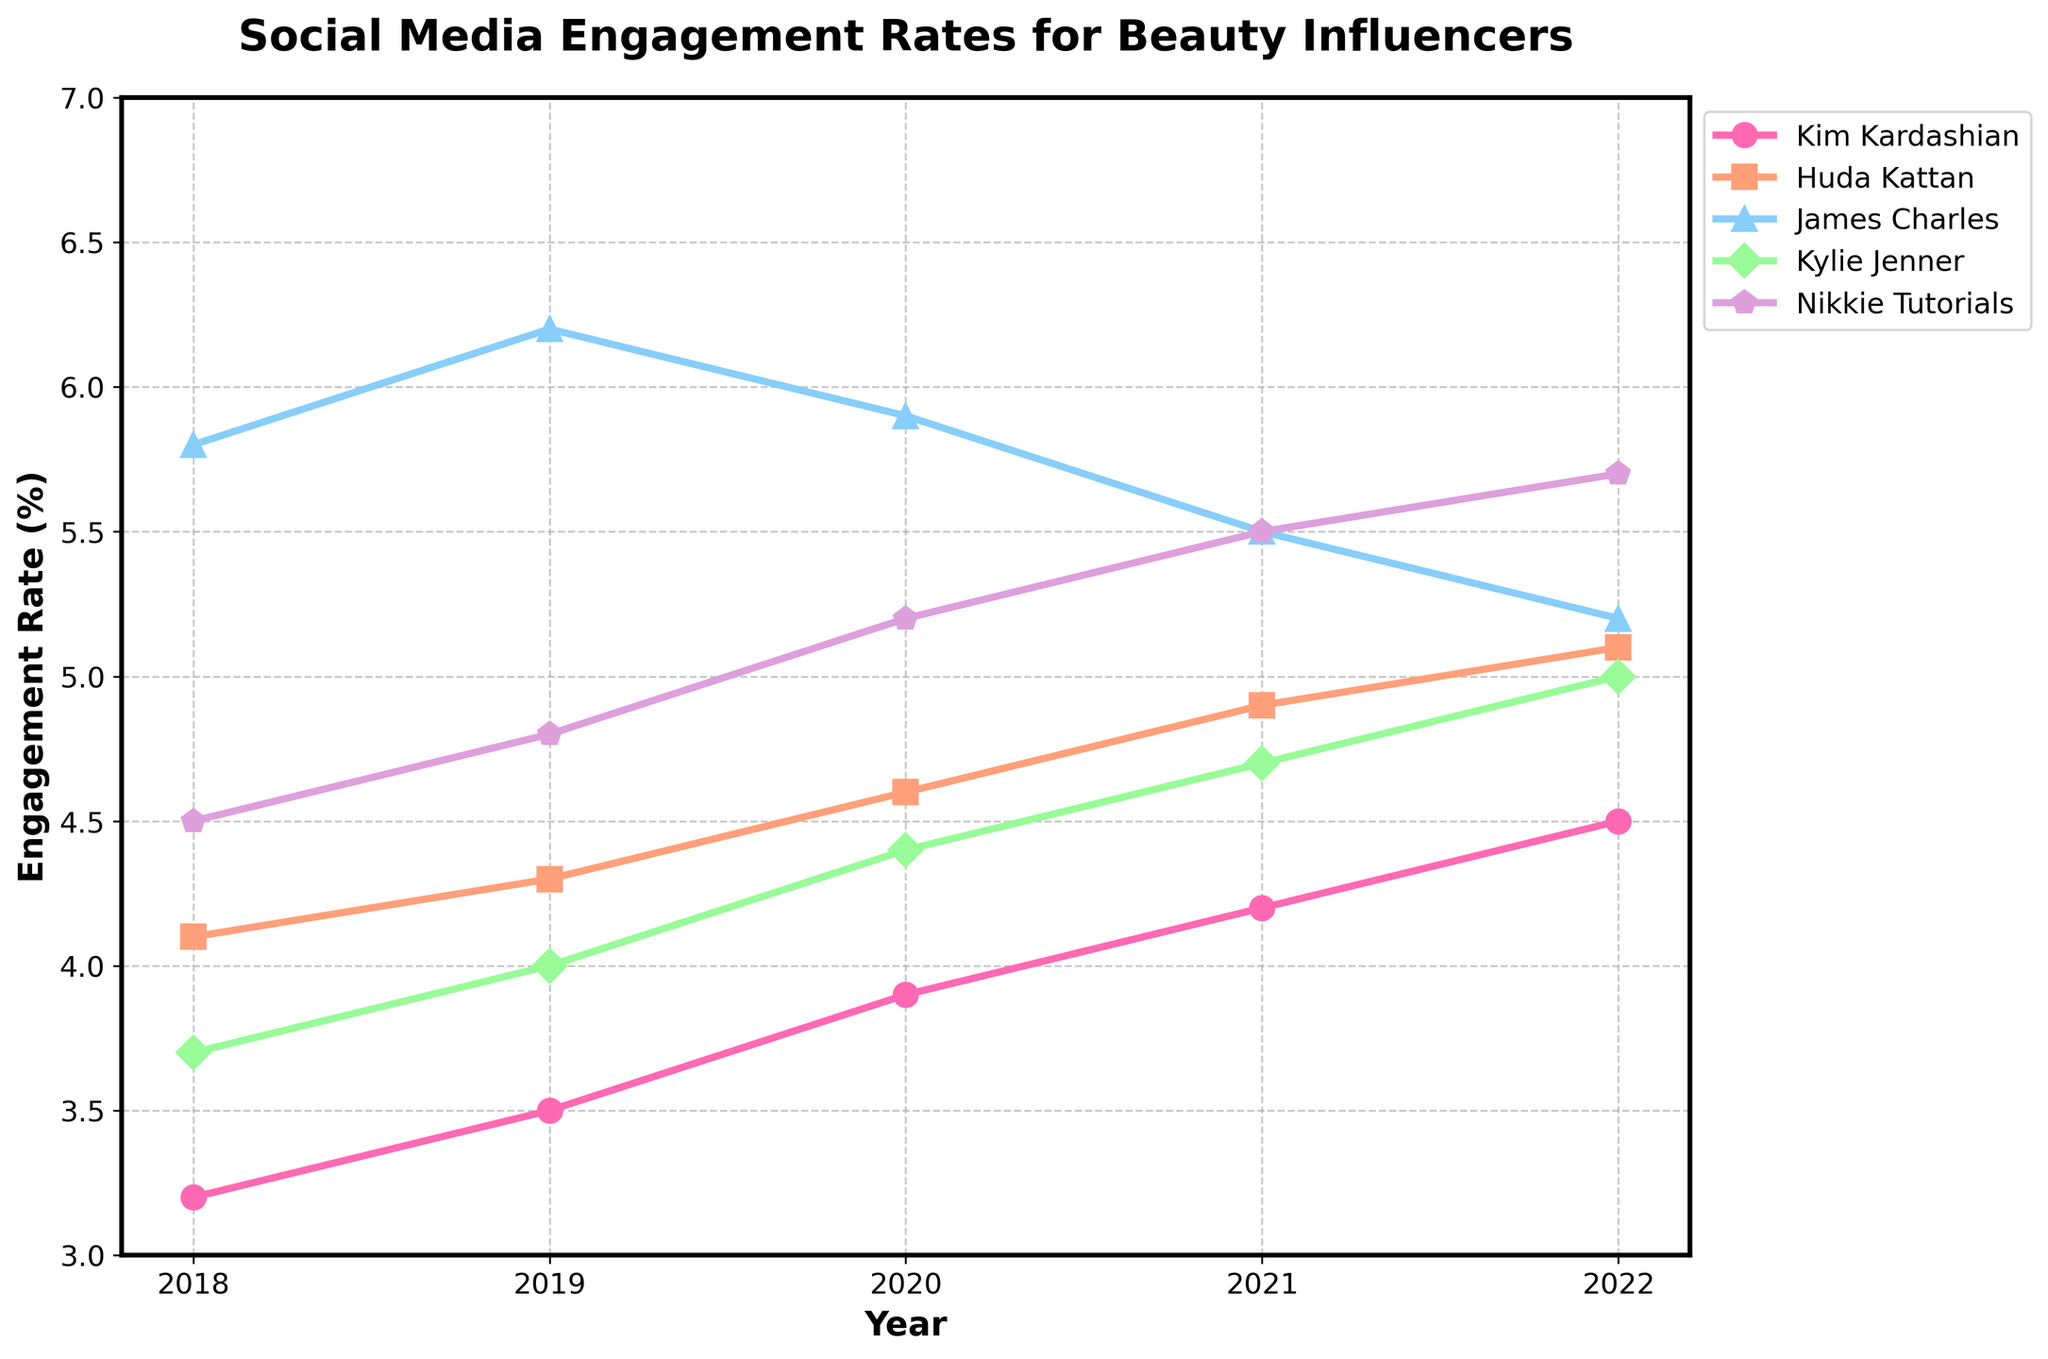Which influencer had the highest engagement rate in 2022? Look at the y-axis value for each influencer in 2022 and see which one is the highest. Nikkie Tutorials has the highest value at around 5.7%.
Answer: Nikkie Tutorials How did Kim Kardashian's engagement rate change from 2018 to 2022? Subtract the engagement rate in 2018 (3.2%) from the rate in 2022 (4.5%). (4.5% - 3.2% = 1.3%)
Answer: Increased by 1.3% Between 2020 and 2021, who had the largest decrease in engagement rate? Compare the engagement rates for all influencers between 2020 and 2021. James Charles had the largest decrease from 5.9% in 2020 to 5.5% in 2021.
Answer: James Charles Which two influencers had identical engagement rates in 2019? Identify the influencers whose engagement rates match in 2019. Nikkie Tutorials and Huda Kattan both had a rate of 4.8%.
Answer: Nikkie Tutorials and Huda Kattan What is the average engagement rate for Kylie Jenner over the 5 years? Add Kylie Jenner's engagement rates for each year and divide by the number of years: (3.7% + 4.0% + 4.4% + 4.7% + 5.0%)/5 = 4.36%
Answer: 4.36% Which influencer had the most consistent engagement rate increase over the five years? Check the rates year-by-year for each influencer. Huda Kattan had a steadily increasing rate each year.
Answer: Huda Kattan Who had a higher engagement rate in 2020, Kim Kardashian or Nikkie Tutorials? Compare the 2020 rates for both influencers. Kim Kardashian had 3.9%, and Nikkie Tutorials had 5.2%.
Answer: Nikkie Tutorials What is the overall trend in social media engagement rates for James Charles from 2018 to 2022? Look at the changes in engagement rate for each year from 2018 to 2022. James Charles's rate increased till 2019, decreased in 2020, and then kept decreasing.
Answer: Decreasing trend Which influencer showed the greatest overall increase in engagement rate from 2018 to 2022? Calculate the increase for each influencer. Kim Kardashian increased from 3.2% to 4.5%, Huda Kattan from 4.1% to 5.1%, James Charles from 5.8% to 5.2%, Kylie Jenner from 3.7% to 5.0%, and Nikkie Tutorials from 4.5% to 5.7%.
Answer: Kylie Jenner How much did Huda Kattan's engagement rate grow from 2018 to 2019 and from 2019 to 2020? Calculate the change for each period: 2019-2018 (4.3% - 4.1% = 0.2%) and 2020-2019 (4.6% - 4.3% = 0.3%). Combined: 0.2% + 0.3% = 0.5%.
Answer: 0.5% 